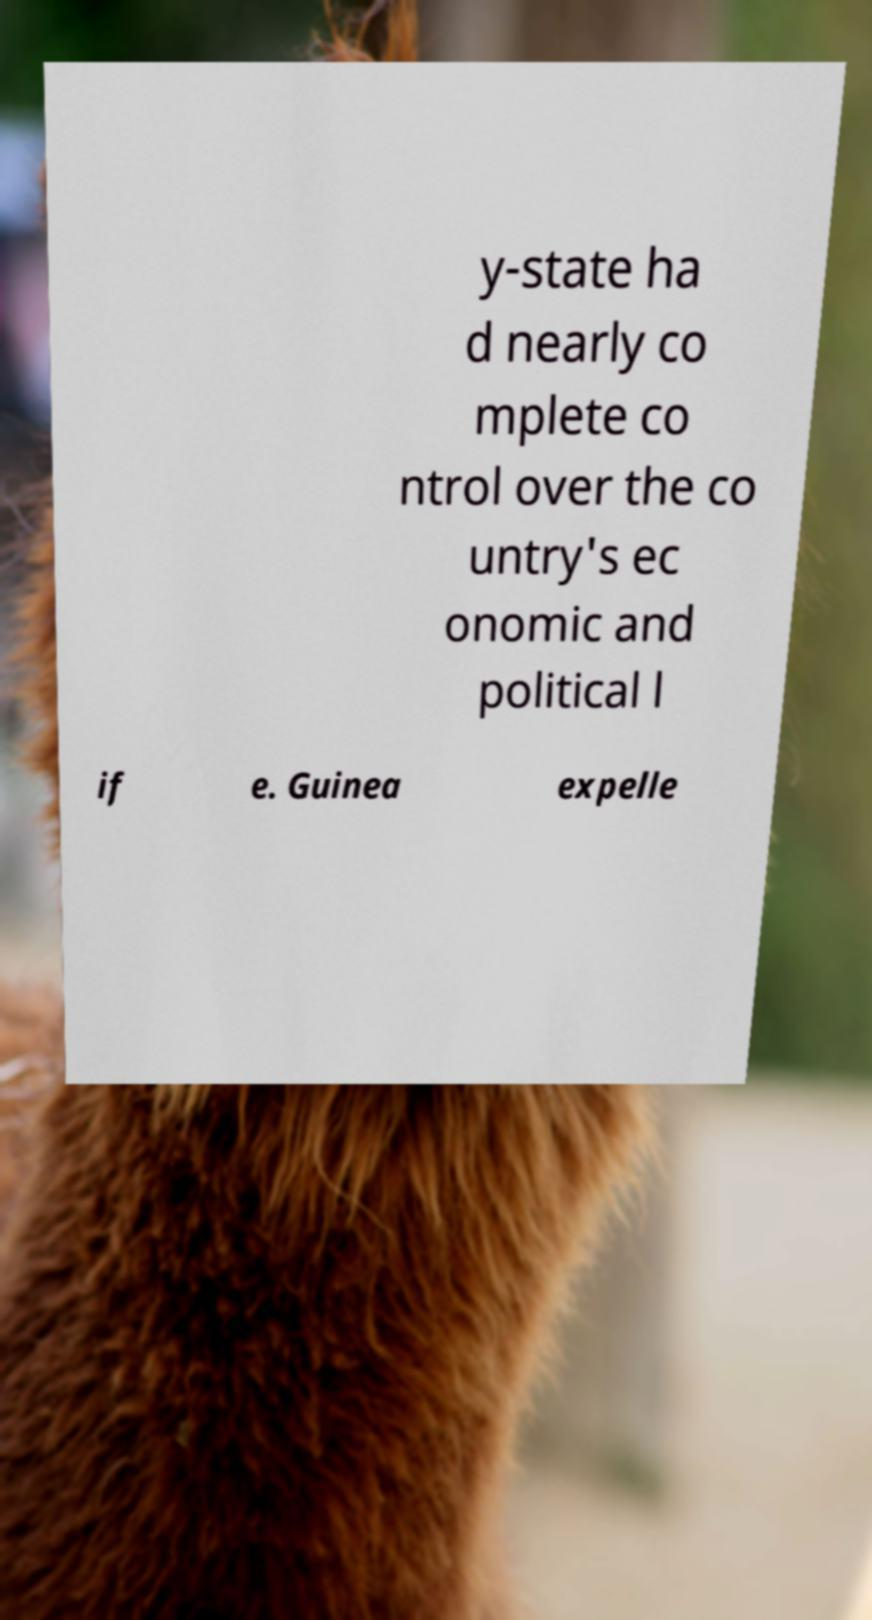There's text embedded in this image that I need extracted. Can you transcribe it verbatim? y-state ha d nearly co mplete co ntrol over the co untry's ec onomic and political l if e. Guinea expelle 